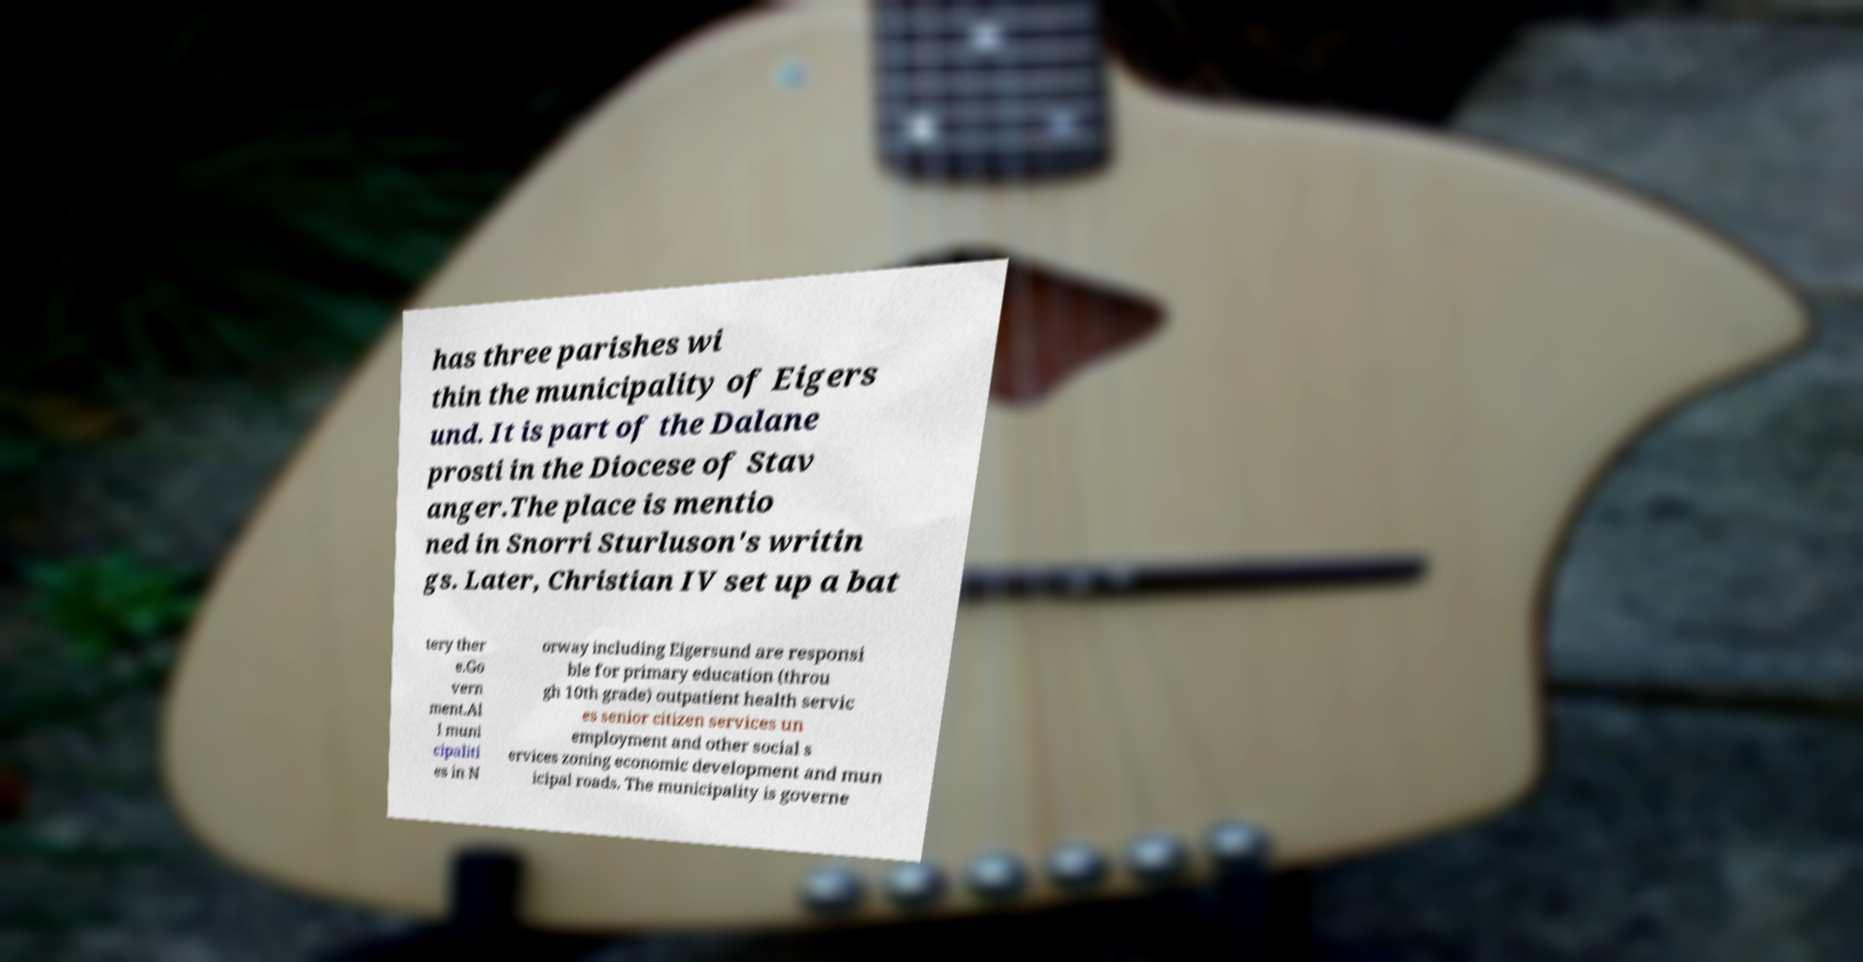For documentation purposes, I need the text within this image transcribed. Could you provide that? has three parishes wi thin the municipality of Eigers und. It is part of the Dalane prosti in the Diocese of Stav anger.The place is mentio ned in Snorri Sturluson's writin gs. Later, Christian IV set up a bat tery ther e.Go vern ment.Al l muni cipaliti es in N orway including Eigersund are responsi ble for primary education (throu gh 10th grade) outpatient health servic es senior citizen services un employment and other social s ervices zoning economic development and mun icipal roads. The municipality is governe 